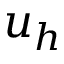<formula> <loc_0><loc_0><loc_500><loc_500>u _ { h }</formula> 